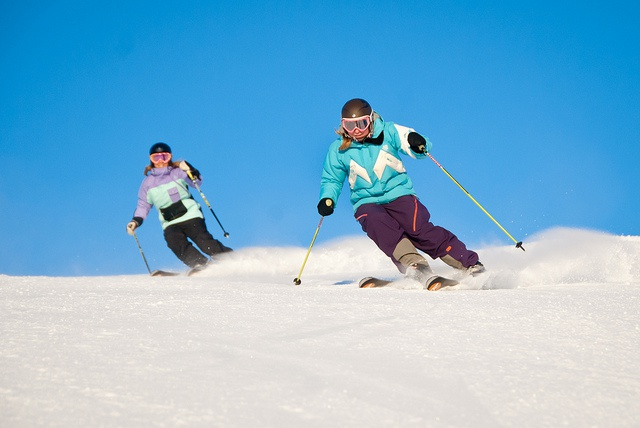Describe the objects in this image and their specific colors. I can see people in gray, purple, turquoise, black, and ivory tones, people in gray, black, beige, and darkgray tones, skis in gray, darkgray, and black tones, and skis in gray and darkgray tones in this image. 